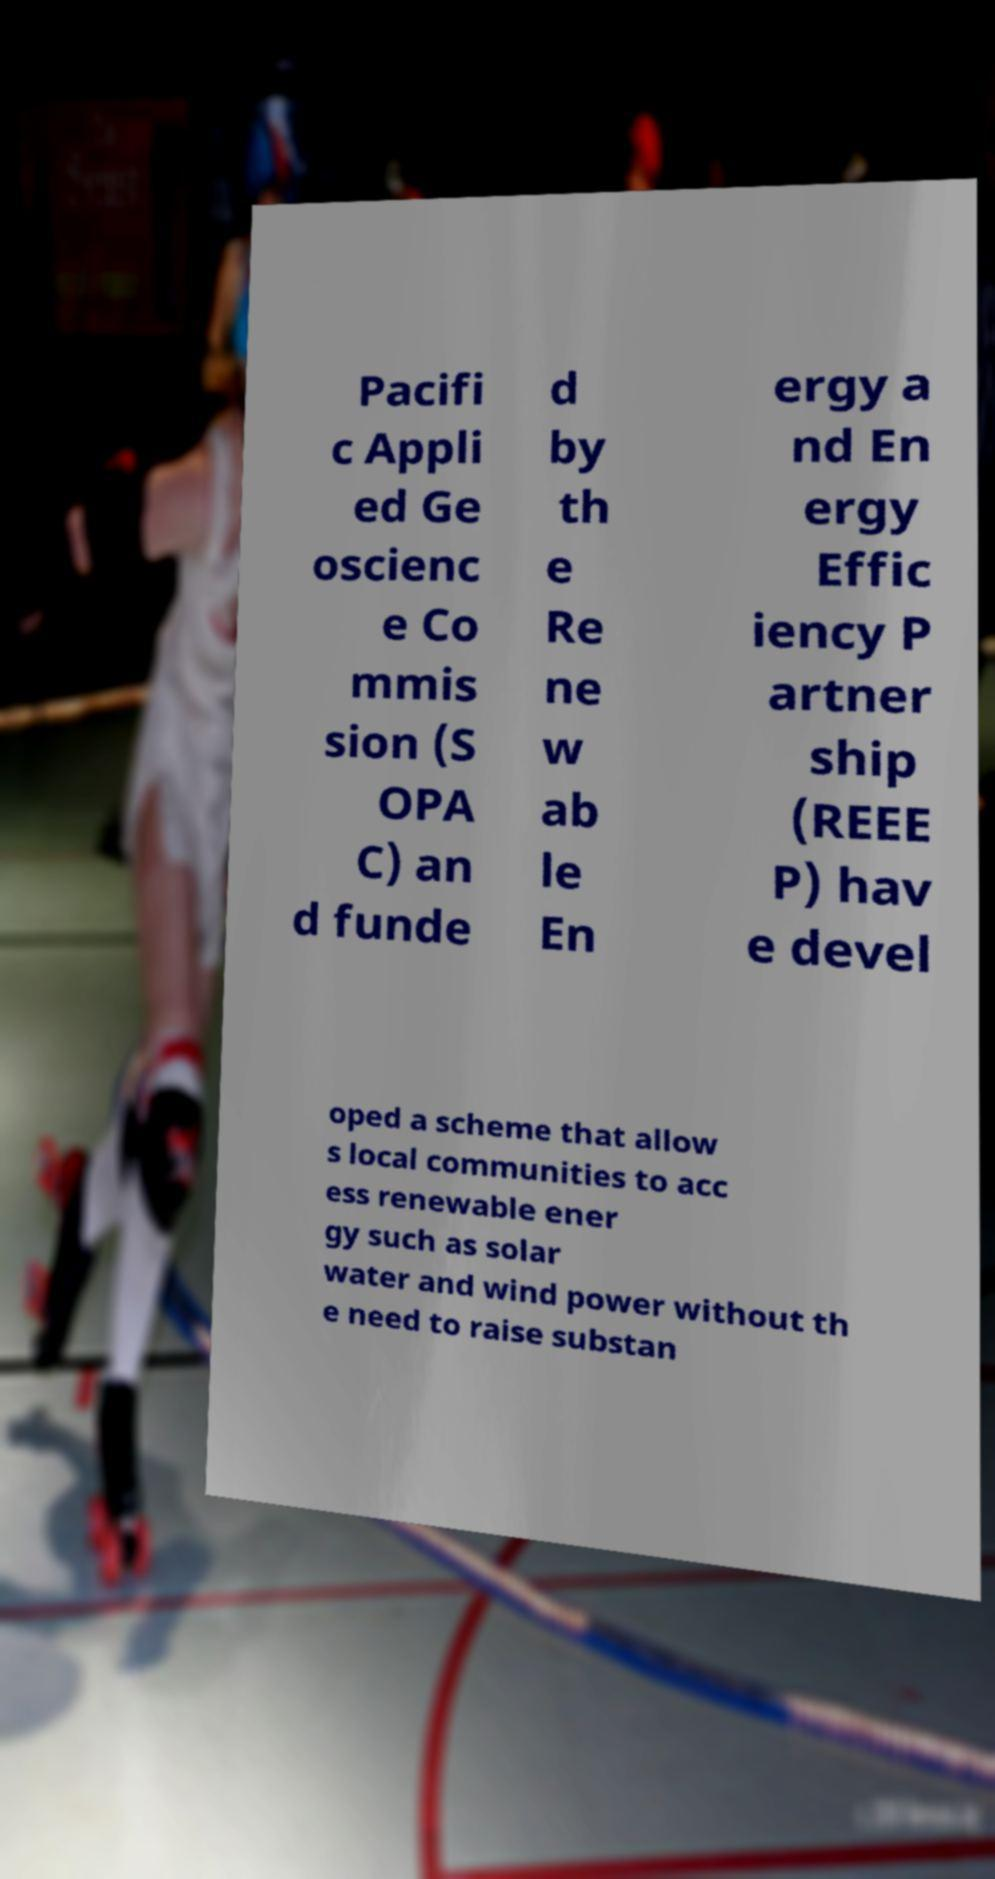I need the written content from this picture converted into text. Can you do that? Pacifi c Appli ed Ge oscienc e Co mmis sion (S OPA C) an d funde d by th e Re ne w ab le En ergy a nd En ergy Effic iency P artner ship (REEE P) hav e devel oped a scheme that allow s local communities to acc ess renewable ener gy such as solar water and wind power without th e need to raise substan 